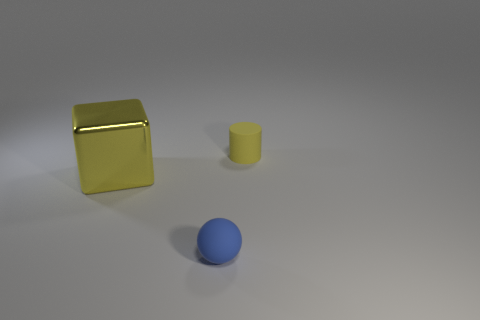Add 2 tiny red matte balls. How many objects exist? 5 Subtract 0 red spheres. How many objects are left? 3 Subtract all cylinders. How many objects are left? 2 Subtract all rubber cylinders. Subtract all tiny cyan matte cubes. How many objects are left? 2 Add 2 yellow metal blocks. How many yellow metal blocks are left? 3 Add 3 big shiny things. How many big shiny things exist? 4 